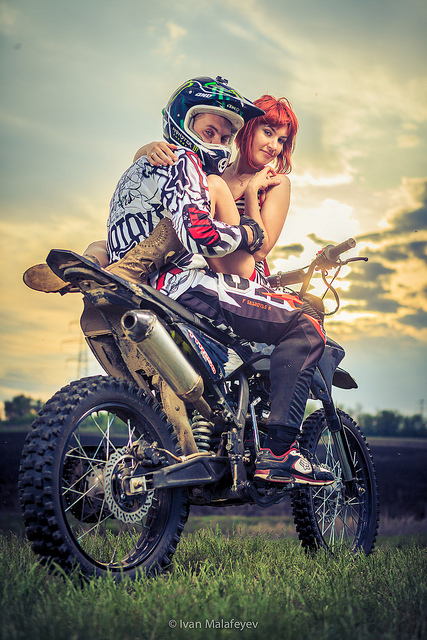Please transcribe the text in this image. Ivan Malafeyev 